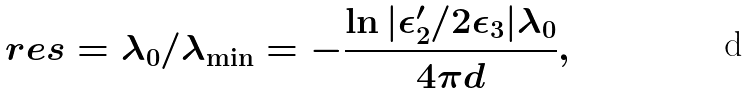<formula> <loc_0><loc_0><loc_500><loc_500>r e s = \lambda _ { 0 } / \lambda _ { \min } = - \frac { \ln | \epsilon _ { 2 } ^ { \prime } / 2 \epsilon _ { 3 } | \lambda _ { 0 } } { 4 \pi d } ,</formula> 